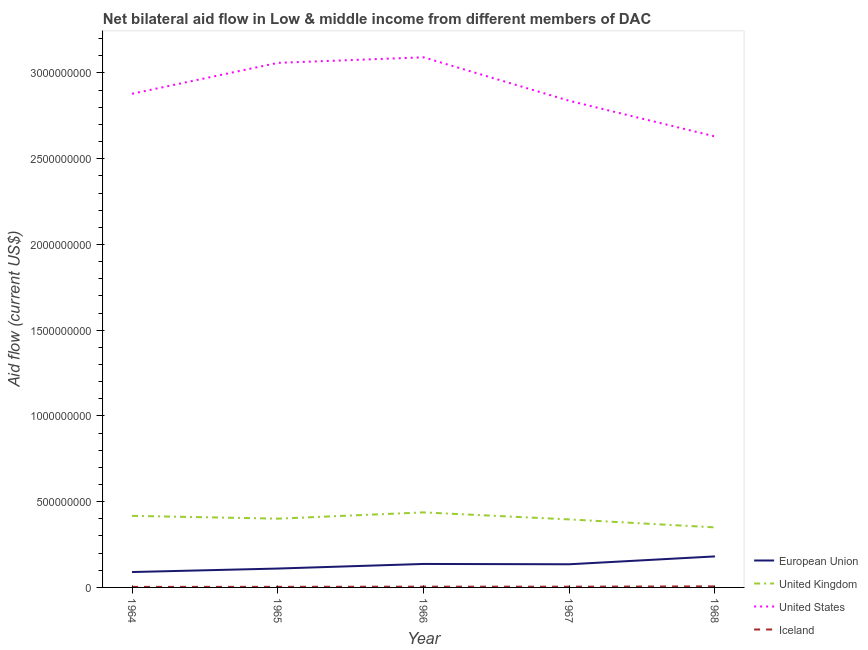Is the number of lines equal to the number of legend labels?
Give a very brief answer. Yes. What is the amount of aid given by us in 1965?
Your answer should be very brief. 3.06e+09. Across all years, what is the maximum amount of aid given by uk?
Offer a terse response. 4.38e+08. Across all years, what is the minimum amount of aid given by eu?
Your answer should be compact. 8.98e+07. In which year was the amount of aid given by iceland maximum?
Make the answer very short. 1968. In which year was the amount of aid given by uk minimum?
Give a very brief answer. 1968. What is the total amount of aid given by iceland in the graph?
Give a very brief answer. 2.16e+07. What is the difference between the amount of aid given by iceland in 1967 and that in 1968?
Offer a terse response. -1.89e+06. What is the difference between the amount of aid given by eu in 1966 and the amount of aid given by uk in 1964?
Make the answer very short. -2.80e+08. What is the average amount of aid given by iceland per year?
Keep it short and to the point. 4.31e+06. In the year 1964, what is the difference between the amount of aid given by us and amount of aid given by uk?
Keep it short and to the point. 2.46e+09. What is the ratio of the amount of aid given by eu in 1964 to that in 1966?
Ensure brevity in your answer.  0.66. Is the amount of aid given by iceland in 1965 less than that in 1966?
Provide a succinct answer. Yes. What is the difference between the highest and the second highest amount of aid given by iceland?
Your answer should be compact. 1.74e+06. What is the difference between the highest and the lowest amount of aid given by eu?
Keep it short and to the point. 9.11e+07. Is it the case that in every year, the sum of the amount of aid given by us and amount of aid given by eu is greater than the sum of amount of aid given by uk and amount of aid given by iceland?
Give a very brief answer. Yes. Is it the case that in every year, the sum of the amount of aid given by eu and amount of aid given by uk is greater than the amount of aid given by us?
Give a very brief answer. No. Does the amount of aid given by eu monotonically increase over the years?
Ensure brevity in your answer.  No. How many legend labels are there?
Ensure brevity in your answer.  4. What is the title of the graph?
Your answer should be compact. Net bilateral aid flow in Low & middle income from different members of DAC. What is the label or title of the Y-axis?
Provide a succinct answer. Aid flow (current US$). What is the Aid flow (current US$) of European Union in 1964?
Provide a succinct answer. 8.98e+07. What is the Aid flow (current US$) in United Kingdom in 1964?
Give a very brief answer. 4.17e+08. What is the Aid flow (current US$) of United States in 1964?
Keep it short and to the point. 2.88e+09. What is the Aid flow (current US$) in Iceland in 1964?
Offer a terse response. 3.18e+06. What is the Aid flow (current US$) of European Union in 1965?
Your response must be concise. 1.10e+08. What is the Aid flow (current US$) of United Kingdom in 1965?
Provide a succinct answer. 4.01e+08. What is the Aid flow (current US$) of United States in 1965?
Ensure brevity in your answer.  3.06e+09. What is the Aid flow (current US$) in Iceland in 1965?
Your response must be concise. 3.44e+06. What is the Aid flow (current US$) of European Union in 1966?
Provide a short and direct response. 1.37e+08. What is the Aid flow (current US$) of United Kingdom in 1966?
Your answer should be compact. 4.38e+08. What is the Aid flow (current US$) of United States in 1966?
Your answer should be very brief. 3.09e+09. What is the Aid flow (current US$) of Iceland in 1966?
Ensure brevity in your answer.  4.45e+06. What is the Aid flow (current US$) of European Union in 1967?
Your response must be concise. 1.35e+08. What is the Aid flow (current US$) in United Kingdom in 1967?
Your response must be concise. 3.97e+08. What is the Aid flow (current US$) of United States in 1967?
Your response must be concise. 2.84e+09. What is the Aid flow (current US$) in Iceland in 1967?
Keep it short and to the point. 4.30e+06. What is the Aid flow (current US$) of European Union in 1968?
Give a very brief answer. 1.81e+08. What is the Aid flow (current US$) in United Kingdom in 1968?
Keep it short and to the point. 3.50e+08. What is the Aid flow (current US$) in United States in 1968?
Give a very brief answer. 2.63e+09. What is the Aid flow (current US$) in Iceland in 1968?
Your response must be concise. 6.19e+06. Across all years, what is the maximum Aid flow (current US$) of European Union?
Offer a very short reply. 1.81e+08. Across all years, what is the maximum Aid flow (current US$) in United Kingdom?
Your answer should be compact. 4.38e+08. Across all years, what is the maximum Aid flow (current US$) of United States?
Keep it short and to the point. 3.09e+09. Across all years, what is the maximum Aid flow (current US$) in Iceland?
Your answer should be compact. 6.19e+06. Across all years, what is the minimum Aid flow (current US$) of European Union?
Make the answer very short. 8.98e+07. Across all years, what is the minimum Aid flow (current US$) in United Kingdom?
Your answer should be very brief. 3.50e+08. Across all years, what is the minimum Aid flow (current US$) in United States?
Provide a succinct answer. 2.63e+09. Across all years, what is the minimum Aid flow (current US$) in Iceland?
Make the answer very short. 3.18e+06. What is the total Aid flow (current US$) in European Union in the graph?
Offer a very short reply. 6.53e+08. What is the total Aid flow (current US$) in United Kingdom in the graph?
Keep it short and to the point. 2.00e+09. What is the total Aid flow (current US$) in United States in the graph?
Offer a very short reply. 1.45e+1. What is the total Aid flow (current US$) in Iceland in the graph?
Your response must be concise. 2.16e+07. What is the difference between the Aid flow (current US$) in European Union in 1964 and that in 1965?
Provide a succinct answer. -2.03e+07. What is the difference between the Aid flow (current US$) of United Kingdom in 1964 and that in 1965?
Give a very brief answer. 1.63e+07. What is the difference between the Aid flow (current US$) in United States in 1964 and that in 1965?
Make the answer very short. -1.80e+08. What is the difference between the Aid flow (current US$) of European Union in 1964 and that in 1966?
Your answer should be compact. -4.71e+07. What is the difference between the Aid flow (current US$) of United Kingdom in 1964 and that in 1966?
Make the answer very short. -2.02e+07. What is the difference between the Aid flow (current US$) of United States in 1964 and that in 1966?
Offer a very short reply. -2.13e+08. What is the difference between the Aid flow (current US$) of Iceland in 1964 and that in 1966?
Your response must be concise. -1.27e+06. What is the difference between the Aid flow (current US$) in European Union in 1964 and that in 1967?
Make the answer very short. -4.53e+07. What is the difference between the Aid flow (current US$) of United Kingdom in 1964 and that in 1967?
Your answer should be very brief. 2.07e+07. What is the difference between the Aid flow (current US$) of United States in 1964 and that in 1967?
Provide a short and direct response. 4.11e+07. What is the difference between the Aid flow (current US$) of Iceland in 1964 and that in 1967?
Provide a short and direct response. -1.12e+06. What is the difference between the Aid flow (current US$) of European Union in 1964 and that in 1968?
Your response must be concise. -9.11e+07. What is the difference between the Aid flow (current US$) in United Kingdom in 1964 and that in 1968?
Your answer should be very brief. 6.72e+07. What is the difference between the Aid flow (current US$) of United States in 1964 and that in 1968?
Provide a short and direct response. 2.49e+08. What is the difference between the Aid flow (current US$) in Iceland in 1964 and that in 1968?
Provide a succinct answer. -3.01e+06. What is the difference between the Aid flow (current US$) of European Union in 1965 and that in 1966?
Make the answer very short. -2.68e+07. What is the difference between the Aid flow (current US$) in United Kingdom in 1965 and that in 1966?
Offer a terse response. -3.65e+07. What is the difference between the Aid flow (current US$) of United States in 1965 and that in 1966?
Make the answer very short. -3.24e+07. What is the difference between the Aid flow (current US$) of Iceland in 1965 and that in 1966?
Give a very brief answer. -1.01e+06. What is the difference between the Aid flow (current US$) in European Union in 1965 and that in 1967?
Provide a short and direct response. -2.50e+07. What is the difference between the Aid flow (current US$) in United Kingdom in 1965 and that in 1967?
Provide a short and direct response. 4.43e+06. What is the difference between the Aid flow (current US$) in United States in 1965 and that in 1967?
Provide a short and direct response. 2.21e+08. What is the difference between the Aid flow (current US$) of Iceland in 1965 and that in 1967?
Offer a very short reply. -8.60e+05. What is the difference between the Aid flow (current US$) in European Union in 1965 and that in 1968?
Provide a succinct answer. -7.07e+07. What is the difference between the Aid flow (current US$) in United Kingdom in 1965 and that in 1968?
Give a very brief answer. 5.10e+07. What is the difference between the Aid flow (current US$) of United States in 1965 and that in 1968?
Provide a short and direct response. 4.29e+08. What is the difference between the Aid flow (current US$) of Iceland in 1965 and that in 1968?
Your answer should be very brief. -2.75e+06. What is the difference between the Aid flow (current US$) of European Union in 1966 and that in 1967?
Offer a very short reply. 1.83e+06. What is the difference between the Aid flow (current US$) of United Kingdom in 1966 and that in 1967?
Offer a terse response. 4.09e+07. What is the difference between the Aid flow (current US$) in United States in 1966 and that in 1967?
Your answer should be very brief. 2.54e+08. What is the difference between the Aid flow (current US$) in European Union in 1966 and that in 1968?
Provide a short and direct response. -4.39e+07. What is the difference between the Aid flow (current US$) of United Kingdom in 1966 and that in 1968?
Offer a terse response. 8.74e+07. What is the difference between the Aid flow (current US$) of United States in 1966 and that in 1968?
Make the answer very short. 4.61e+08. What is the difference between the Aid flow (current US$) in Iceland in 1966 and that in 1968?
Provide a succinct answer. -1.74e+06. What is the difference between the Aid flow (current US$) of European Union in 1967 and that in 1968?
Provide a short and direct response. -4.58e+07. What is the difference between the Aid flow (current US$) of United Kingdom in 1967 and that in 1968?
Offer a very short reply. 4.65e+07. What is the difference between the Aid flow (current US$) in United States in 1967 and that in 1968?
Your response must be concise. 2.08e+08. What is the difference between the Aid flow (current US$) of Iceland in 1967 and that in 1968?
Offer a very short reply. -1.89e+06. What is the difference between the Aid flow (current US$) of European Union in 1964 and the Aid flow (current US$) of United Kingdom in 1965?
Your response must be concise. -3.11e+08. What is the difference between the Aid flow (current US$) in European Union in 1964 and the Aid flow (current US$) in United States in 1965?
Your response must be concise. -2.97e+09. What is the difference between the Aid flow (current US$) of European Union in 1964 and the Aid flow (current US$) of Iceland in 1965?
Offer a very short reply. 8.64e+07. What is the difference between the Aid flow (current US$) of United Kingdom in 1964 and the Aid flow (current US$) of United States in 1965?
Your answer should be very brief. -2.64e+09. What is the difference between the Aid flow (current US$) of United Kingdom in 1964 and the Aid flow (current US$) of Iceland in 1965?
Your answer should be very brief. 4.14e+08. What is the difference between the Aid flow (current US$) of United States in 1964 and the Aid flow (current US$) of Iceland in 1965?
Offer a terse response. 2.88e+09. What is the difference between the Aid flow (current US$) of European Union in 1964 and the Aid flow (current US$) of United Kingdom in 1966?
Provide a succinct answer. -3.48e+08. What is the difference between the Aid flow (current US$) of European Union in 1964 and the Aid flow (current US$) of United States in 1966?
Offer a very short reply. -3.00e+09. What is the difference between the Aid flow (current US$) in European Union in 1964 and the Aid flow (current US$) in Iceland in 1966?
Offer a very short reply. 8.54e+07. What is the difference between the Aid flow (current US$) in United Kingdom in 1964 and the Aid flow (current US$) in United States in 1966?
Provide a short and direct response. -2.67e+09. What is the difference between the Aid flow (current US$) in United Kingdom in 1964 and the Aid flow (current US$) in Iceland in 1966?
Your answer should be compact. 4.13e+08. What is the difference between the Aid flow (current US$) of United States in 1964 and the Aid flow (current US$) of Iceland in 1966?
Your answer should be very brief. 2.87e+09. What is the difference between the Aid flow (current US$) of European Union in 1964 and the Aid flow (current US$) of United Kingdom in 1967?
Ensure brevity in your answer.  -3.07e+08. What is the difference between the Aid flow (current US$) in European Union in 1964 and the Aid flow (current US$) in United States in 1967?
Ensure brevity in your answer.  -2.75e+09. What is the difference between the Aid flow (current US$) of European Union in 1964 and the Aid flow (current US$) of Iceland in 1967?
Your answer should be compact. 8.55e+07. What is the difference between the Aid flow (current US$) of United Kingdom in 1964 and the Aid flow (current US$) of United States in 1967?
Make the answer very short. -2.42e+09. What is the difference between the Aid flow (current US$) of United Kingdom in 1964 and the Aid flow (current US$) of Iceland in 1967?
Give a very brief answer. 4.13e+08. What is the difference between the Aid flow (current US$) of United States in 1964 and the Aid flow (current US$) of Iceland in 1967?
Offer a terse response. 2.87e+09. What is the difference between the Aid flow (current US$) of European Union in 1964 and the Aid flow (current US$) of United Kingdom in 1968?
Offer a terse response. -2.60e+08. What is the difference between the Aid flow (current US$) in European Union in 1964 and the Aid flow (current US$) in United States in 1968?
Keep it short and to the point. -2.54e+09. What is the difference between the Aid flow (current US$) of European Union in 1964 and the Aid flow (current US$) of Iceland in 1968?
Give a very brief answer. 8.36e+07. What is the difference between the Aid flow (current US$) of United Kingdom in 1964 and the Aid flow (current US$) of United States in 1968?
Your answer should be very brief. -2.21e+09. What is the difference between the Aid flow (current US$) in United Kingdom in 1964 and the Aid flow (current US$) in Iceland in 1968?
Your answer should be very brief. 4.11e+08. What is the difference between the Aid flow (current US$) in United States in 1964 and the Aid flow (current US$) in Iceland in 1968?
Your answer should be compact. 2.87e+09. What is the difference between the Aid flow (current US$) in European Union in 1965 and the Aid flow (current US$) in United Kingdom in 1966?
Your response must be concise. -3.27e+08. What is the difference between the Aid flow (current US$) of European Union in 1965 and the Aid flow (current US$) of United States in 1966?
Offer a very short reply. -2.98e+09. What is the difference between the Aid flow (current US$) of European Union in 1965 and the Aid flow (current US$) of Iceland in 1966?
Make the answer very short. 1.06e+08. What is the difference between the Aid flow (current US$) of United Kingdom in 1965 and the Aid flow (current US$) of United States in 1966?
Ensure brevity in your answer.  -2.69e+09. What is the difference between the Aid flow (current US$) of United Kingdom in 1965 and the Aid flow (current US$) of Iceland in 1966?
Make the answer very short. 3.97e+08. What is the difference between the Aid flow (current US$) in United States in 1965 and the Aid flow (current US$) in Iceland in 1966?
Provide a succinct answer. 3.05e+09. What is the difference between the Aid flow (current US$) of European Union in 1965 and the Aid flow (current US$) of United Kingdom in 1967?
Keep it short and to the point. -2.86e+08. What is the difference between the Aid flow (current US$) in European Union in 1965 and the Aid flow (current US$) in United States in 1967?
Ensure brevity in your answer.  -2.73e+09. What is the difference between the Aid flow (current US$) of European Union in 1965 and the Aid flow (current US$) of Iceland in 1967?
Provide a succinct answer. 1.06e+08. What is the difference between the Aid flow (current US$) of United Kingdom in 1965 and the Aid flow (current US$) of United States in 1967?
Offer a terse response. -2.44e+09. What is the difference between the Aid flow (current US$) of United Kingdom in 1965 and the Aid flow (current US$) of Iceland in 1967?
Ensure brevity in your answer.  3.97e+08. What is the difference between the Aid flow (current US$) in United States in 1965 and the Aid flow (current US$) in Iceland in 1967?
Make the answer very short. 3.05e+09. What is the difference between the Aid flow (current US$) of European Union in 1965 and the Aid flow (current US$) of United Kingdom in 1968?
Your response must be concise. -2.40e+08. What is the difference between the Aid flow (current US$) in European Union in 1965 and the Aid flow (current US$) in United States in 1968?
Provide a short and direct response. -2.52e+09. What is the difference between the Aid flow (current US$) in European Union in 1965 and the Aid flow (current US$) in Iceland in 1968?
Your answer should be very brief. 1.04e+08. What is the difference between the Aid flow (current US$) of United Kingdom in 1965 and the Aid flow (current US$) of United States in 1968?
Keep it short and to the point. -2.23e+09. What is the difference between the Aid flow (current US$) in United Kingdom in 1965 and the Aid flow (current US$) in Iceland in 1968?
Your answer should be very brief. 3.95e+08. What is the difference between the Aid flow (current US$) in United States in 1965 and the Aid flow (current US$) in Iceland in 1968?
Ensure brevity in your answer.  3.05e+09. What is the difference between the Aid flow (current US$) in European Union in 1966 and the Aid flow (current US$) in United Kingdom in 1967?
Offer a very short reply. -2.60e+08. What is the difference between the Aid flow (current US$) of European Union in 1966 and the Aid flow (current US$) of United States in 1967?
Offer a very short reply. -2.70e+09. What is the difference between the Aid flow (current US$) in European Union in 1966 and the Aid flow (current US$) in Iceland in 1967?
Provide a short and direct response. 1.33e+08. What is the difference between the Aid flow (current US$) in United Kingdom in 1966 and the Aid flow (current US$) in United States in 1967?
Your answer should be very brief. -2.40e+09. What is the difference between the Aid flow (current US$) in United Kingdom in 1966 and the Aid flow (current US$) in Iceland in 1967?
Offer a terse response. 4.33e+08. What is the difference between the Aid flow (current US$) of United States in 1966 and the Aid flow (current US$) of Iceland in 1967?
Ensure brevity in your answer.  3.09e+09. What is the difference between the Aid flow (current US$) of European Union in 1966 and the Aid flow (current US$) of United Kingdom in 1968?
Ensure brevity in your answer.  -2.13e+08. What is the difference between the Aid flow (current US$) in European Union in 1966 and the Aid flow (current US$) in United States in 1968?
Make the answer very short. -2.49e+09. What is the difference between the Aid flow (current US$) of European Union in 1966 and the Aid flow (current US$) of Iceland in 1968?
Ensure brevity in your answer.  1.31e+08. What is the difference between the Aid flow (current US$) of United Kingdom in 1966 and the Aid flow (current US$) of United States in 1968?
Ensure brevity in your answer.  -2.19e+09. What is the difference between the Aid flow (current US$) of United Kingdom in 1966 and the Aid flow (current US$) of Iceland in 1968?
Keep it short and to the point. 4.31e+08. What is the difference between the Aid flow (current US$) of United States in 1966 and the Aid flow (current US$) of Iceland in 1968?
Offer a terse response. 3.09e+09. What is the difference between the Aid flow (current US$) of European Union in 1967 and the Aid flow (current US$) of United Kingdom in 1968?
Provide a succinct answer. -2.15e+08. What is the difference between the Aid flow (current US$) of European Union in 1967 and the Aid flow (current US$) of United States in 1968?
Make the answer very short. -2.50e+09. What is the difference between the Aid flow (current US$) of European Union in 1967 and the Aid flow (current US$) of Iceland in 1968?
Offer a terse response. 1.29e+08. What is the difference between the Aid flow (current US$) in United Kingdom in 1967 and the Aid flow (current US$) in United States in 1968?
Provide a short and direct response. -2.23e+09. What is the difference between the Aid flow (current US$) of United Kingdom in 1967 and the Aid flow (current US$) of Iceland in 1968?
Provide a succinct answer. 3.90e+08. What is the difference between the Aid flow (current US$) in United States in 1967 and the Aid flow (current US$) in Iceland in 1968?
Provide a short and direct response. 2.83e+09. What is the average Aid flow (current US$) in European Union per year?
Make the answer very short. 1.31e+08. What is the average Aid flow (current US$) in United Kingdom per year?
Make the answer very short. 4.01e+08. What is the average Aid flow (current US$) in United States per year?
Offer a terse response. 2.90e+09. What is the average Aid flow (current US$) of Iceland per year?
Ensure brevity in your answer.  4.31e+06. In the year 1964, what is the difference between the Aid flow (current US$) of European Union and Aid flow (current US$) of United Kingdom?
Give a very brief answer. -3.28e+08. In the year 1964, what is the difference between the Aid flow (current US$) in European Union and Aid flow (current US$) in United States?
Give a very brief answer. -2.79e+09. In the year 1964, what is the difference between the Aid flow (current US$) of European Union and Aid flow (current US$) of Iceland?
Offer a terse response. 8.66e+07. In the year 1964, what is the difference between the Aid flow (current US$) in United Kingdom and Aid flow (current US$) in United States?
Ensure brevity in your answer.  -2.46e+09. In the year 1964, what is the difference between the Aid flow (current US$) in United Kingdom and Aid flow (current US$) in Iceland?
Provide a short and direct response. 4.14e+08. In the year 1964, what is the difference between the Aid flow (current US$) in United States and Aid flow (current US$) in Iceland?
Offer a terse response. 2.88e+09. In the year 1965, what is the difference between the Aid flow (current US$) of European Union and Aid flow (current US$) of United Kingdom?
Provide a succinct answer. -2.91e+08. In the year 1965, what is the difference between the Aid flow (current US$) of European Union and Aid flow (current US$) of United States?
Offer a terse response. -2.95e+09. In the year 1965, what is the difference between the Aid flow (current US$) in European Union and Aid flow (current US$) in Iceland?
Your response must be concise. 1.07e+08. In the year 1965, what is the difference between the Aid flow (current US$) in United Kingdom and Aid flow (current US$) in United States?
Offer a very short reply. -2.66e+09. In the year 1965, what is the difference between the Aid flow (current US$) of United Kingdom and Aid flow (current US$) of Iceland?
Offer a very short reply. 3.98e+08. In the year 1965, what is the difference between the Aid flow (current US$) of United States and Aid flow (current US$) of Iceland?
Offer a terse response. 3.06e+09. In the year 1966, what is the difference between the Aid flow (current US$) of European Union and Aid flow (current US$) of United Kingdom?
Ensure brevity in your answer.  -3.01e+08. In the year 1966, what is the difference between the Aid flow (current US$) in European Union and Aid flow (current US$) in United States?
Make the answer very short. -2.95e+09. In the year 1966, what is the difference between the Aid flow (current US$) in European Union and Aid flow (current US$) in Iceland?
Your response must be concise. 1.32e+08. In the year 1966, what is the difference between the Aid flow (current US$) of United Kingdom and Aid flow (current US$) of United States?
Give a very brief answer. -2.65e+09. In the year 1966, what is the difference between the Aid flow (current US$) in United Kingdom and Aid flow (current US$) in Iceland?
Keep it short and to the point. 4.33e+08. In the year 1966, what is the difference between the Aid flow (current US$) in United States and Aid flow (current US$) in Iceland?
Your answer should be compact. 3.09e+09. In the year 1967, what is the difference between the Aid flow (current US$) in European Union and Aid flow (current US$) in United Kingdom?
Provide a short and direct response. -2.62e+08. In the year 1967, what is the difference between the Aid flow (current US$) of European Union and Aid flow (current US$) of United States?
Offer a very short reply. -2.70e+09. In the year 1967, what is the difference between the Aid flow (current US$) in European Union and Aid flow (current US$) in Iceland?
Offer a very short reply. 1.31e+08. In the year 1967, what is the difference between the Aid flow (current US$) in United Kingdom and Aid flow (current US$) in United States?
Offer a terse response. -2.44e+09. In the year 1967, what is the difference between the Aid flow (current US$) in United Kingdom and Aid flow (current US$) in Iceland?
Your answer should be very brief. 3.92e+08. In the year 1967, what is the difference between the Aid flow (current US$) in United States and Aid flow (current US$) in Iceland?
Ensure brevity in your answer.  2.83e+09. In the year 1968, what is the difference between the Aid flow (current US$) of European Union and Aid flow (current US$) of United Kingdom?
Provide a short and direct response. -1.69e+08. In the year 1968, what is the difference between the Aid flow (current US$) in European Union and Aid flow (current US$) in United States?
Make the answer very short. -2.45e+09. In the year 1968, what is the difference between the Aid flow (current US$) of European Union and Aid flow (current US$) of Iceland?
Ensure brevity in your answer.  1.75e+08. In the year 1968, what is the difference between the Aid flow (current US$) of United Kingdom and Aid flow (current US$) of United States?
Offer a very short reply. -2.28e+09. In the year 1968, what is the difference between the Aid flow (current US$) in United Kingdom and Aid flow (current US$) in Iceland?
Your answer should be compact. 3.44e+08. In the year 1968, what is the difference between the Aid flow (current US$) in United States and Aid flow (current US$) in Iceland?
Keep it short and to the point. 2.62e+09. What is the ratio of the Aid flow (current US$) of European Union in 1964 to that in 1965?
Ensure brevity in your answer.  0.82. What is the ratio of the Aid flow (current US$) of United Kingdom in 1964 to that in 1965?
Your response must be concise. 1.04. What is the ratio of the Aid flow (current US$) in United States in 1964 to that in 1965?
Provide a short and direct response. 0.94. What is the ratio of the Aid flow (current US$) of Iceland in 1964 to that in 1965?
Your answer should be compact. 0.92. What is the ratio of the Aid flow (current US$) in European Union in 1964 to that in 1966?
Offer a very short reply. 0.66. What is the ratio of the Aid flow (current US$) of United Kingdom in 1964 to that in 1966?
Ensure brevity in your answer.  0.95. What is the ratio of the Aid flow (current US$) of United States in 1964 to that in 1966?
Offer a very short reply. 0.93. What is the ratio of the Aid flow (current US$) of Iceland in 1964 to that in 1966?
Keep it short and to the point. 0.71. What is the ratio of the Aid flow (current US$) of European Union in 1964 to that in 1967?
Keep it short and to the point. 0.66. What is the ratio of the Aid flow (current US$) in United Kingdom in 1964 to that in 1967?
Your response must be concise. 1.05. What is the ratio of the Aid flow (current US$) in United States in 1964 to that in 1967?
Provide a succinct answer. 1.01. What is the ratio of the Aid flow (current US$) of Iceland in 1964 to that in 1967?
Keep it short and to the point. 0.74. What is the ratio of the Aid flow (current US$) in European Union in 1964 to that in 1968?
Your answer should be very brief. 0.5. What is the ratio of the Aid flow (current US$) of United Kingdom in 1964 to that in 1968?
Your answer should be compact. 1.19. What is the ratio of the Aid flow (current US$) in United States in 1964 to that in 1968?
Offer a very short reply. 1.09. What is the ratio of the Aid flow (current US$) of Iceland in 1964 to that in 1968?
Provide a short and direct response. 0.51. What is the ratio of the Aid flow (current US$) in European Union in 1965 to that in 1966?
Keep it short and to the point. 0.8. What is the ratio of the Aid flow (current US$) in United Kingdom in 1965 to that in 1966?
Offer a terse response. 0.92. What is the ratio of the Aid flow (current US$) in United States in 1965 to that in 1966?
Provide a succinct answer. 0.99. What is the ratio of the Aid flow (current US$) in Iceland in 1965 to that in 1966?
Offer a terse response. 0.77. What is the ratio of the Aid flow (current US$) of European Union in 1965 to that in 1967?
Provide a short and direct response. 0.82. What is the ratio of the Aid flow (current US$) in United Kingdom in 1965 to that in 1967?
Offer a terse response. 1.01. What is the ratio of the Aid flow (current US$) of United States in 1965 to that in 1967?
Your answer should be very brief. 1.08. What is the ratio of the Aid flow (current US$) of Iceland in 1965 to that in 1967?
Make the answer very short. 0.8. What is the ratio of the Aid flow (current US$) in European Union in 1965 to that in 1968?
Your answer should be compact. 0.61. What is the ratio of the Aid flow (current US$) of United Kingdom in 1965 to that in 1968?
Your answer should be very brief. 1.15. What is the ratio of the Aid flow (current US$) of United States in 1965 to that in 1968?
Give a very brief answer. 1.16. What is the ratio of the Aid flow (current US$) of Iceland in 1965 to that in 1968?
Your answer should be very brief. 0.56. What is the ratio of the Aid flow (current US$) of European Union in 1966 to that in 1967?
Make the answer very short. 1.01. What is the ratio of the Aid flow (current US$) of United Kingdom in 1966 to that in 1967?
Provide a succinct answer. 1.1. What is the ratio of the Aid flow (current US$) of United States in 1966 to that in 1967?
Your answer should be compact. 1.09. What is the ratio of the Aid flow (current US$) in Iceland in 1966 to that in 1967?
Your response must be concise. 1.03. What is the ratio of the Aid flow (current US$) of European Union in 1966 to that in 1968?
Keep it short and to the point. 0.76. What is the ratio of the Aid flow (current US$) in United Kingdom in 1966 to that in 1968?
Ensure brevity in your answer.  1.25. What is the ratio of the Aid flow (current US$) in United States in 1966 to that in 1968?
Your response must be concise. 1.18. What is the ratio of the Aid flow (current US$) in Iceland in 1966 to that in 1968?
Keep it short and to the point. 0.72. What is the ratio of the Aid flow (current US$) of European Union in 1967 to that in 1968?
Provide a succinct answer. 0.75. What is the ratio of the Aid flow (current US$) in United Kingdom in 1967 to that in 1968?
Your answer should be very brief. 1.13. What is the ratio of the Aid flow (current US$) of United States in 1967 to that in 1968?
Ensure brevity in your answer.  1.08. What is the ratio of the Aid flow (current US$) in Iceland in 1967 to that in 1968?
Your answer should be very brief. 0.69. What is the difference between the highest and the second highest Aid flow (current US$) in European Union?
Ensure brevity in your answer.  4.39e+07. What is the difference between the highest and the second highest Aid flow (current US$) in United Kingdom?
Your answer should be compact. 2.02e+07. What is the difference between the highest and the second highest Aid flow (current US$) in United States?
Your answer should be compact. 3.24e+07. What is the difference between the highest and the second highest Aid flow (current US$) in Iceland?
Offer a very short reply. 1.74e+06. What is the difference between the highest and the lowest Aid flow (current US$) of European Union?
Offer a terse response. 9.11e+07. What is the difference between the highest and the lowest Aid flow (current US$) of United Kingdom?
Ensure brevity in your answer.  8.74e+07. What is the difference between the highest and the lowest Aid flow (current US$) in United States?
Your answer should be very brief. 4.61e+08. What is the difference between the highest and the lowest Aid flow (current US$) of Iceland?
Your answer should be very brief. 3.01e+06. 